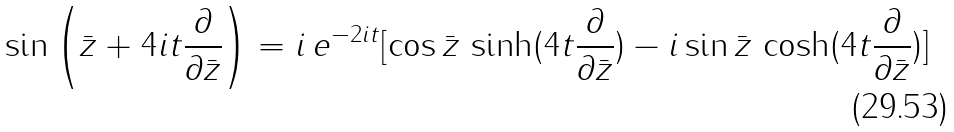<formula> <loc_0><loc_0><loc_500><loc_500>\sin \left ( \bar { z } + 4 i t \frac { \partial } { \partial \bar { z } } \right ) = i \, e ^ { - 2 i t } [ \cos \bar { z } \, \sinh ( 4 t \frac { \partial } { \partial \bar { z } } ) - i \sin \bar { z } \, \cosh ( 4 t \frac { \partial } { \partial \bar { z } } ) ]</formula> 